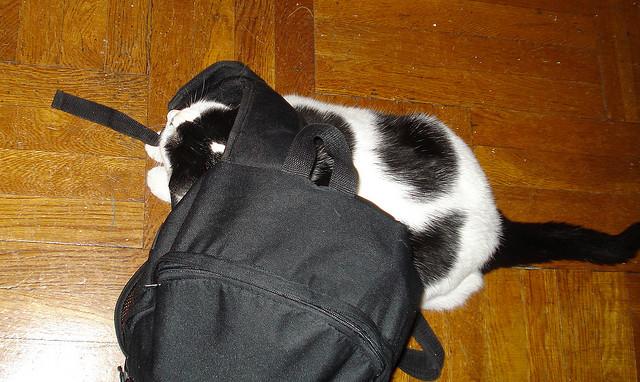Why did the cat end up like this?
Concise answer only. Playing. What has uneven squares?
Answer briefly. Floor. Is the cat sleeping under a backpack?
Short answer required. Yes. 